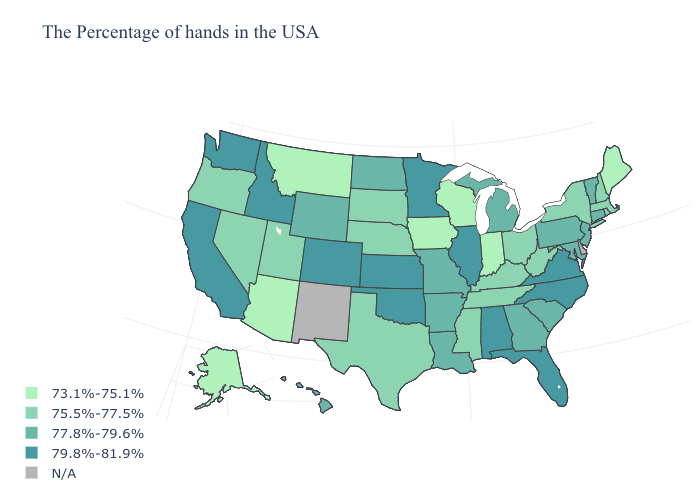What is the value of Wyoming?
Keep it brief. 77.8%-79.6%. What is the value of Michigan?
Give a very brief answer. 77.8%-79.6%. Does Florida have the lowest value in the USA?
Concise answer only. No. How many symbols are there in the legend?
Give a very brief answer. 5. Which states have the lowest value in the West?
Short answer required. Montana, Arizona, Alaska. Which states have the highest value in the USA?
Answer briefly. Virginia, North Carolina, Florida, Alabama, Illinois, Minnesota, Kansas, Oklahoma, Colorado, Idaho, California, Washington. What is the value of Montana?
Quick response, please. 73.1%-75.1%. Which states have the lowest value in the USA?
Be succinct. Maine, Indiana, Wisconsin, Iowa, Montana, Arizona, Alaska. Does the first symbol in the legend represent the smallest category?
Short answer required. Yes. Among the states that border Missouri , does Kansas have the highest value?
Short answer required. Yes. What is the value of Utah?
Be succinct. 75.5%-77.5%. Which states have the lowest value in the South?
Keep it brief. West Virginia, Kentucky, Tennessee, Mississippi, Texas. What is the value of Maryland?
Give a very brief answer. 77.8%-79.6%. Is the legend a continuous bar?
Give a very brief answer. No. 